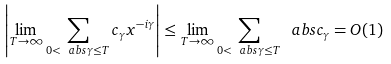Convert formula to latex. <formula><loc_0><loc_0><loc_500><loc_500>\left | \lim _ { T \to \infty } \sum _ { 0 < \ a b s { \gamma } \leq T } c _ { \gamma } x ^ { - i \gamma } \right | \leq \lim _ { T \to \infty } \sum _ { 0 < \ a b s { \gamma } \leq T } \ a b s { c _ { \gamma } } = O ( 1 )</formula> 